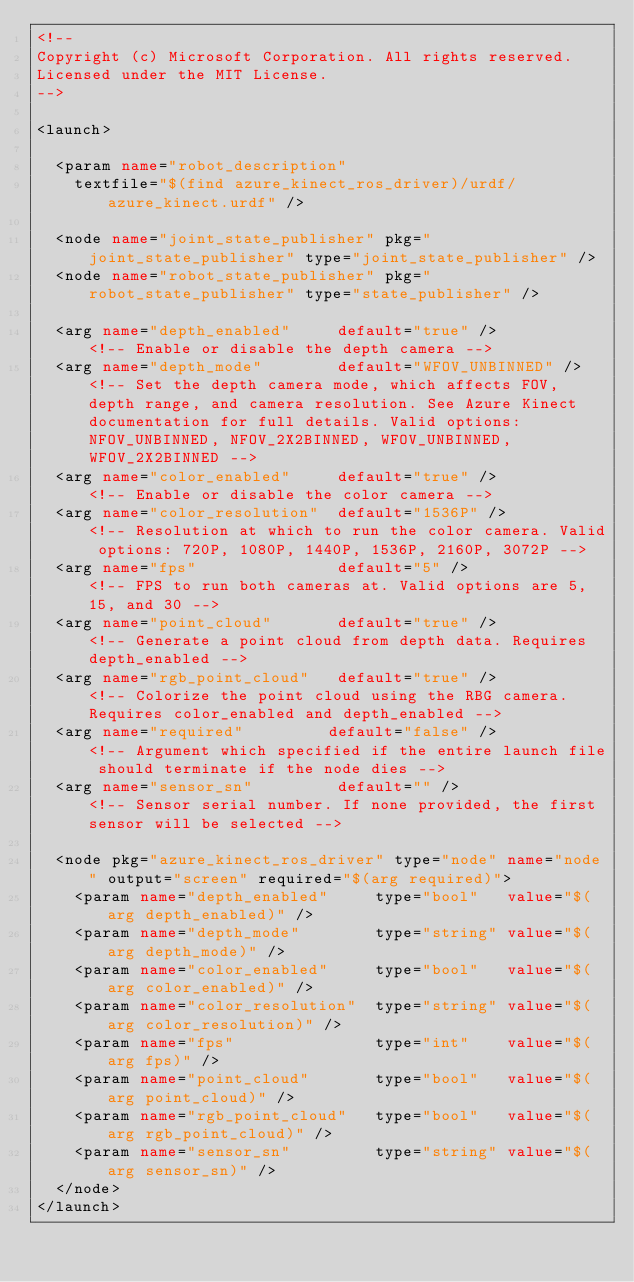<code> <loc_0><loc_0><loc_500><loc_500><_XML_><!-- 
Copyright (c) Microsoft Corporation. All rights reserved.
Licensed under the MIT License.
-->

<launch>

  <param name="robot_description"
    textfile="$(find azure_kinect_ros_driver)/urdf/azure_kinect.urdf" />

  <node name="joint_state_publisher" pkg="joint_state_publisher" type="joint_state_publisher" />
  <node name="robot_state_publisher" pkg="robot_state_publisher" type="state_publisher" />

  <arg name="depth_enabled"     default="true" />           <!-- Enable or disable the depth camera -->
  <arg name="depth_mode"        default="WFOV_UNBINNED" />  <!-- Set the depth camera mode, which affects FOV, depth range, and camera resolution. See Azure Kinect documentation for full details. Valid options: NFOV_UNBINNED, NFOV_2X2BINNED, WFOV_UNBINNED, WFOV_2X2BINNED -->
  <arg name="color_enabled"     default="true" />           <!-- Enable or disable the color camera -->
  <arg name="color_resolution"  default="1536P" />          <!-- Resolution at which to run the color camera. Valid options: 720P, 1080P, 1440P, 1536P, 2160P, 3072P -->
  <arg name="fps"               default="5" />             <!-- FPS to run both cameras at. Valid options are 5, 15, and 30 -->
  <arg name="point_cloud"       default="true" />           <!-- Generate a point cloud from depth data. Requires depth_enabled -->
  <arg name="rgb_point_cloud"   default="true" />           <!-- Colorize the point cloud using the RBG camera. Requires color_enabled and depth_enabled -->
  <arg name="required"         default="false" />          <!-- Argument which specified if the entire launch file should terminate if the node dies -->
  <arg name="sensor_sn"         default="" />               <!-- Sensor serial number. If none provided, the first sensor will be selected -->

  <node pkg="azure_kinect_ros_driver" type="node" name="node" output="screen" required="$(arg required)">
    <param name="depth_enabled"     type="bool"   value="$(arg depth_enabled)" /> 
    <param name="depth_mode"        type="string" value="$(arg depth_mode)" /> 
    <param name="color_enabled"     type="bool"   value="$(arg color_enabled)" /> 
    <param name="color_resolution"  type="string" value="$(arg color_resolution)" /> 
    <param name="fps"               type="int"    value="$(arg fps)" /> 
    <param name="point_cloud"       type="bool"   value="$(arg point_cloud)" /> 
    <param name="rgb_point_cloud"   type="bool"   value="$(arg rgb_point_cloud)" /> 
    <param name="sensor_sn"         type="string" value="$(arg sensor_sn)" />
  </node>
</launch></code> 